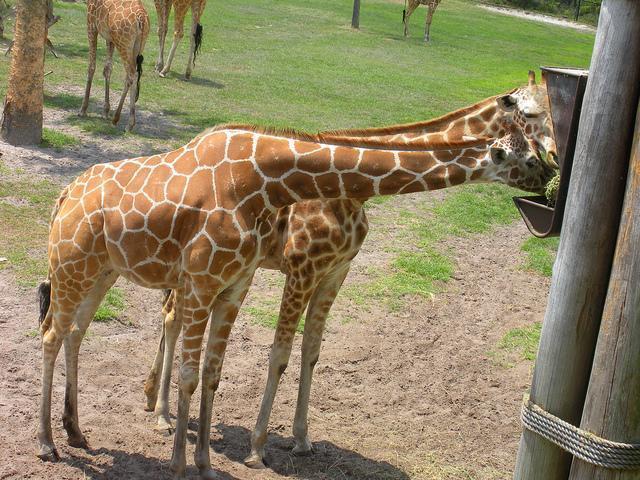How many giraffes are in the photo?
Give a very brief answer. 4. 